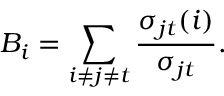Convert formula to latex. <formula><loc_0><loc_0><loc_500><loc_500>B _ { i } = \sum _ { i \neq j \neq t } \frac { \sigma _ { j t } ( i ) } { \sigma _ { j t } } .</formula> 